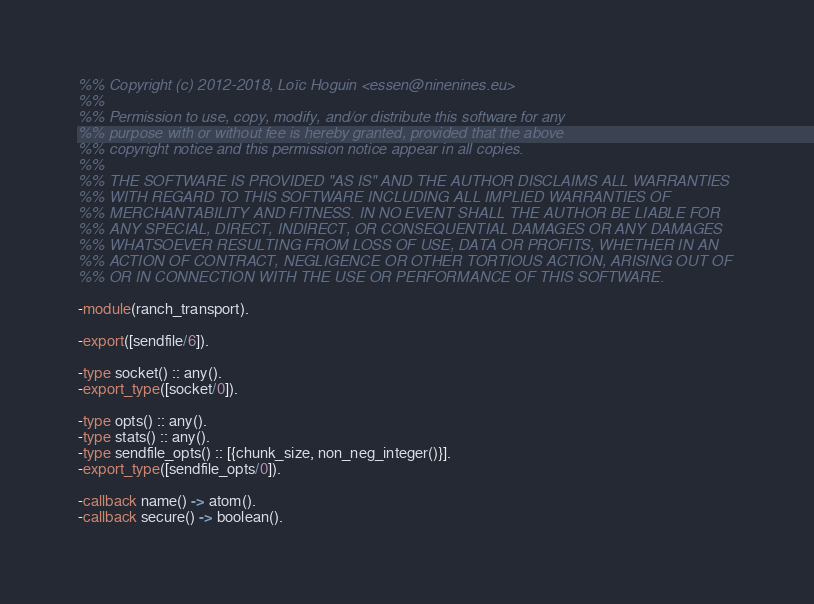<code> <loc_0><loc_0><loc_500><loc_500><_Erlang_>%% Copyright (c) 2012-2018, Loïc Hoguin <essen@ninenines.eu>
%%
%% Permission to use, copy, modify, and/or distribute this software for any
%% purpose with or without fee is hereby granted, provided that the above
%% copyright notice and this permission notice appear in all copies.
%%
%% THE SOFTWARE IS PROVIDED "AS IS" AND THE AUTHOR DISCLAIMS ALL WARRANTIES
%% WITH REGARD TO THIS SOFTWARE INCLUDING ALL IMPLIED WARRANTIES OF
%% MERCHANTABILITY AND FITNESS. IN NO EVENT SHALL THE AUTHOR BE LIABLE FOR
%% ANY SPECIAL, DIRECT, INDIRECT, OR CONSEQUENTIAL DAMAGES OR ANY DAMAGES
%% WHATSOEVER RESULTING FROM LOSS OF USE, DATA OR PROFITS, WHETHER IN AN
%% ACTION OF CONTRACT, NEGLIGENCE OR OTHER TORTIOUS ACTION, ARISING OUT OF
%% OR IN CONNECTION WITH THE USE OR PERFORMANCE OF THIS SOFTWARE.

-module(ranch_transport).

-export([sendfile/6]).

-type socket() :: any().
-export_type([socket/0]).

-type opts() :: any().
-type stats() :: any().
-type sendfile_opts() :: [{chunk_size, non_neg_integer()}].
-export_type([sendfile_opts/0]).

-callback name() -> atom().
-callback secure() -> boolean().</code> 